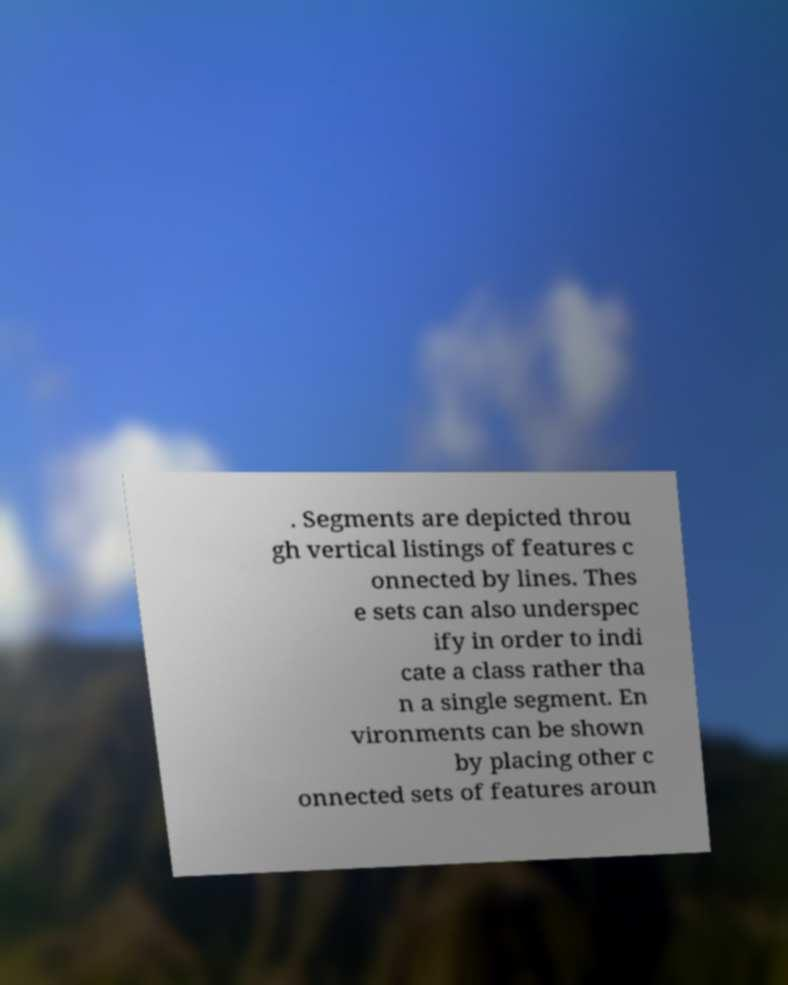Could you assist in decoding the text presented in this image and type it out clearly? . Segments are depicted throu gh vertical listings of features c onnected by lines. Thes e sets can also underspec ify in order to indi cate a class rather tha n a single segment. En vironments can be shown by placing other c onnected sets of features aroun 